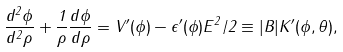<formula> <loc_0><loc_0><loc_500><loc_500>\frac { d ^ { 2 } \phi } { d ^ { 2 } \rho } + \frac { 1 } { \rho } \frac { d \phi } { d \rho } = V ^ { \prime } ( \phi ) - \epsilon ^ { \prime } ( \phi ) E ^ { 2 } / 2 \equiv | B | K ^ { \prime } ( \phi , \theta ) ,</formula> 